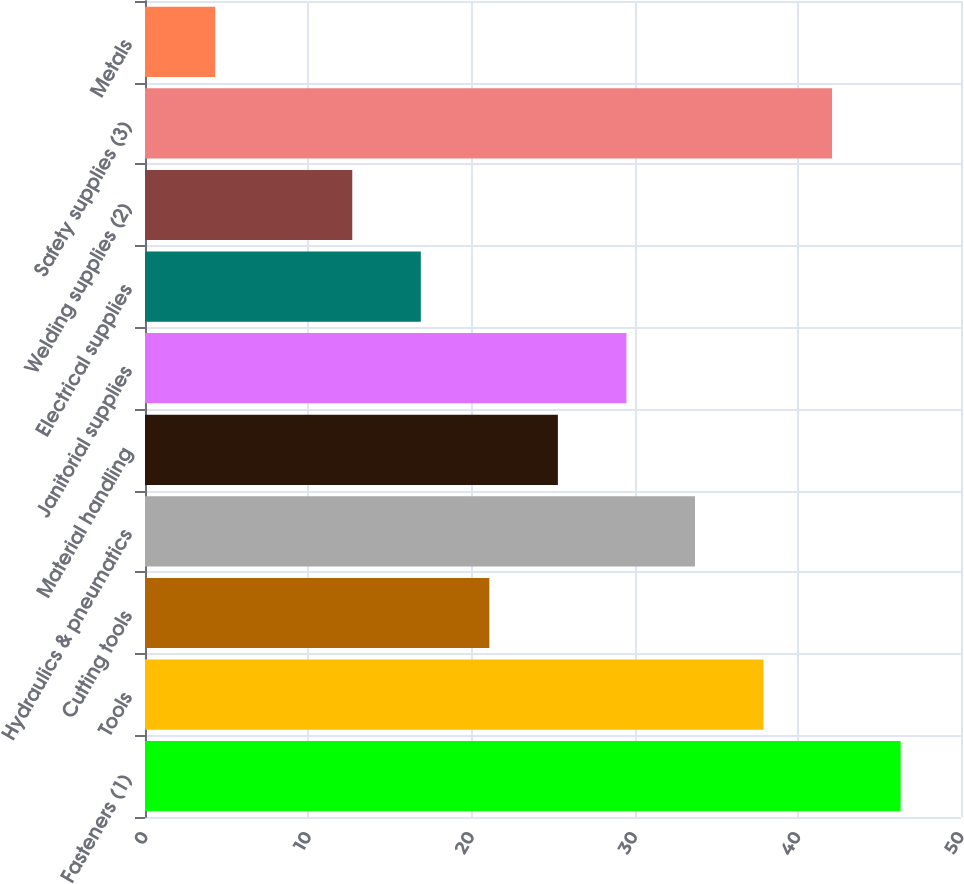<chart> <loc_0><loc_0><loc_500><loc_500><bar_chart><fcel>Fasteners (1)<fcel>Tools<fcel>Cutting tools<fcel>Hydraulics & pneumatics<fcel>Material handling<fcel>Janitorial supplies<fcel>Electrical supplies<fcel>Welding supplies (2)<fcel>Safety supplies (3)<fcel>Metals<nl><fcel>46.3<fcel>37.9<fcel>21.1<fcel>33.7<fcel>25.3<fcel>29.5<fcel>16.9<fcel>12.7<fcel>42.1<fcel>4.3<nl></chart> 